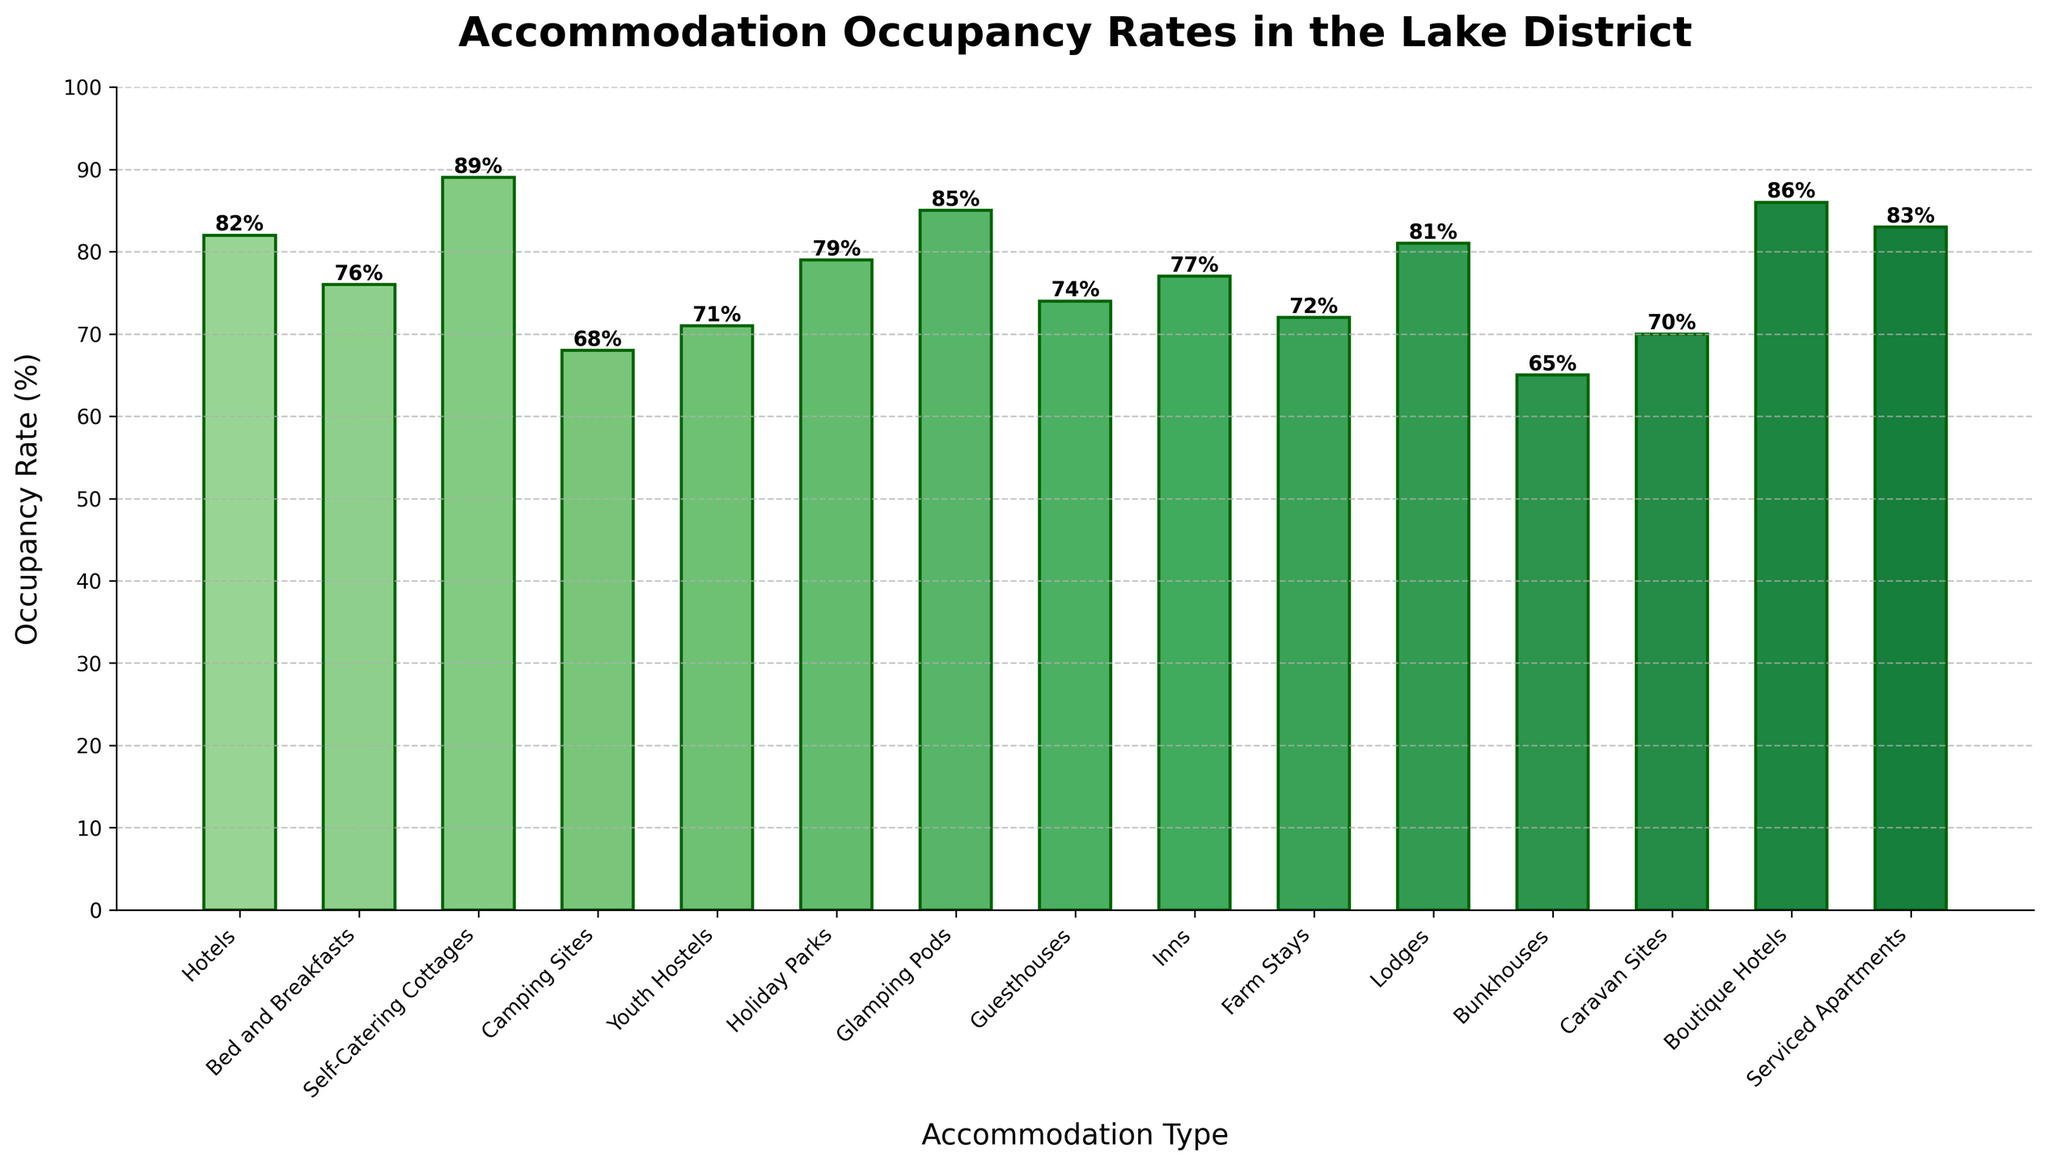What's the highest occupancy rate among all accommodation types? The figure shows the occupancy rates for various accommodation types in the Lake District. The highest bar represents the highest occupancy rate. Based on the visual height of the bars, identify the tallest one. Here, Self-Catering Cottages have an occupancy rate of 89%, which is the highest.
Answer: 89% Which accommodation type has the lowest occupancy rate? Analyze the bars in the chart to find the shortest one, which indicates the lowest occupancy rate. Bunkhouses have the shortest bar with an occupancy rate of 65%, making it the lowest among the types.
Answer: Bunkhouses Compare the occupancy rates of Hotels and Boutique Hotels. Which one is higher and by how much? To compare, look at the heights of the bars for Hotels and Boutique Hotels. Hotels have an occupancy rate of 82%, while Boutique Hotels have an occupancy rate of 86%. Subtract the lower value from the higher one (86% - 82% = 4%). Thus, Boutique Hotels have a 4% higher occupancy rate than Hotels.
Answer: Boutique Hotels, 4% What is the average occupancy rate of Guesthouses, Inns, and Farm Stays? First, locate the bars for Guesthouses, Inns, and Farm Stays and note their occupancy rates: 74%, 77%, and 72% respectively. Add these rates together (74% + 77% + 72% = 223%), then divide by the number of accommodation types (3) to get the average (223% / 3 = 74.33%).
Answer: 74.33% Identify the accommodation types with an occupancy rate higher than 80%. Inspect the bars and their corresponding occupancy rates to see which ones exceed 80%. The accommodation types with rates higher than 80% are Hotels (82%), Self-Catering Cottages (89%), Glamping Pods (85%), Boutique Hotels (86%), and Serviced Apartments (83%).
Answer: Hotels, Self-Catering Cottages, Glamping Pods, Boutique Hotels, Serviced Apartments What's the difference in occupancy rates between Camping Sites and Caravan Sites? Find and compare the bars for Camping Sites and Caravan Sites. Camping Sites have an occupancy rate of 68%, while Caravan Sites have 70%. The difference is calculated by subtracting the smaller percentage from the larger one (70% - 68% = 2%).
Answer: 2% What is the combined occupancy rate of Youth Hostels and Farm Stays? Locate the bars for Youth Hostels and Farm Stays and record their occupancy rates: 71% for Youth Hostels and 72% for Farm Stays. Add these rates together to find the combined occupancy rate (71% + 72% = 143%).
Answer: 143% Which accommodation type has a higher occupancy rate, Bed and Breakfasts or Guesthouses, and what is the rate difference? Compare the heights of the bars for Bed and Breakfasts and Guesthouses. Bed and Breakfasts have an occupancy rate of 76%, while Guesthouses have 74%. Subtract the smaller rate from the larger one (76% - 74% = 2%). Therefore, Bed and Breakfasts have a 2% higher occupancy rate.
Answer: Bed and Breakfasts, 2% What is the median occupancy rate among all accommodation types? First, list the occupancy rates in ascending order: 65%, 68%, 70%, 71%, 72%, 74%, 76%, 77%, 79%, 81%, 82%, 83%, 85%, 86%, 89%. The median is the middle value of this ordered list. With 15 data points, the median is the 8th entry, which is 77%.
Answer: 77% Which two accommodation types have the closest occupancy rates and what are their rates? Review and compare the heights of all bars to find the two closest in value. Hotels have 82% and Lodges have 81%, with a 1% difference, which is the smallest difference among the pairs.
Answer: Hotels (82%) and Lodges (81%) 